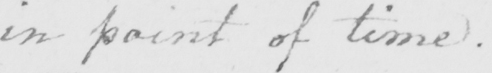Can you read and transcribe this handwriting? in point of time. 